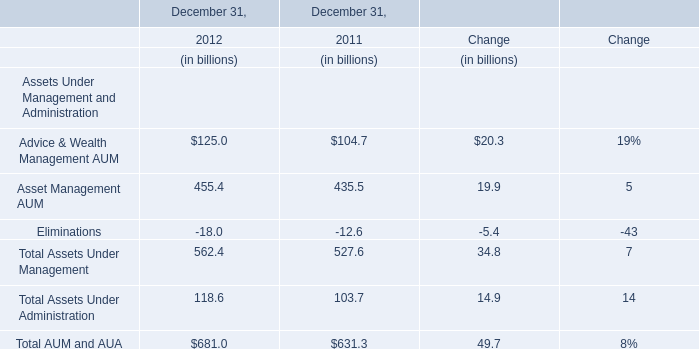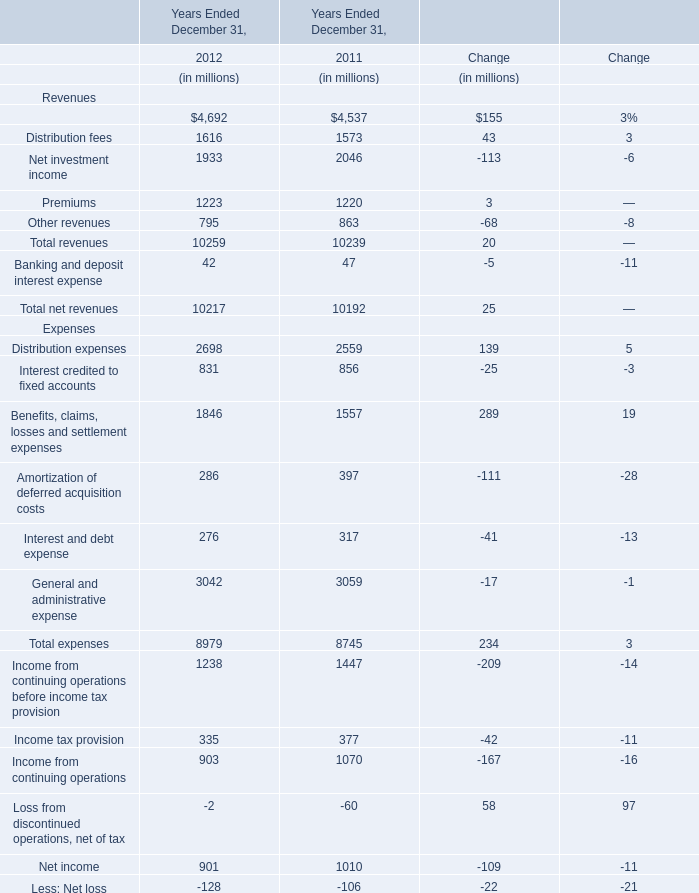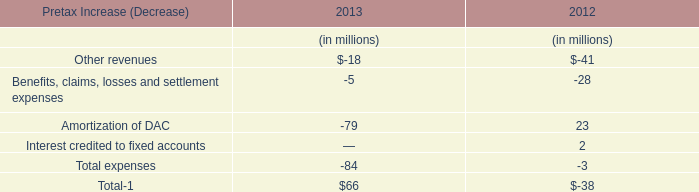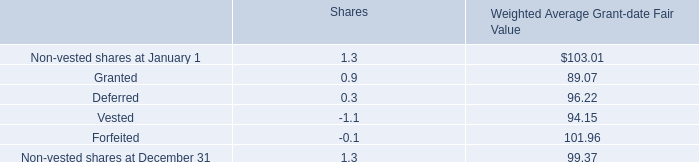What's the 2012 growth rate of Total AUM and AUA? 
Computations: ((681 - 631.3) / 631.3)
Answer: 0.07873. 